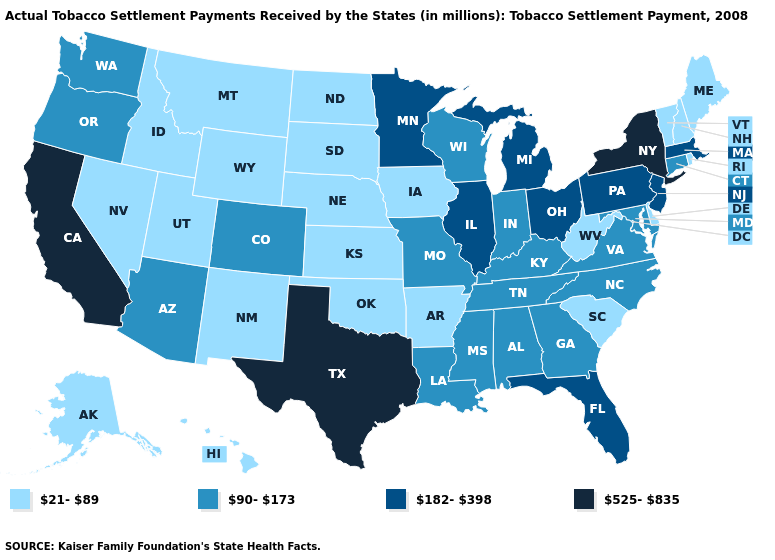Among the states that border Massachusetts , which have the lowest value?
Be succinct. New Hampshire, Rhode Island, Vermont. What is the value of Nebraska?
Write a very short answer. 21-89. Does New York have a higher value than Texas?
Concise answer only. No. Name the states that have a value in the range 90-173?
Write a very short answer. Alabama, Arizona, Colorado, Connecticut, Georgia, Indiana, Kentucky, Louisiana, Maryland, Mississippi, Missouri, North Carolina, Oregon, Tennessee, Virginia, Washington, Wisconsin. Name the states that have a value in the range 525-835?
Concise answer only. California, New York, Texas. Among the states that border Iowa , does South Dakota have the highest value?
Quick response, please. No. Does Wyoming have a lower value than California?
Concise answer only. Yes. What is the value of New York?
Concise answer only. 525-835. Is the legend a continuous bar?
Keep it brief. No. Does Oklahoma have the same value as Iowa?
Quick response, please. Yes. What is the value of North Dakota?
Short answer required. 21-89. Does Oregon have a higher value than Indiana?
Short answer required. No. Name the states that have a value in the range 182-398?
Write a very short answer. Florida, Illinois, Massachusetts, Michigan, Minnesota, New Jersey, Ohio, Pennsylvania. Name the states that have a value in the range 90-173?
Short answer required. Alabama, Arizona, Colorado, Connecticut, Georgia, Indiana, Kentucky, Louisiana, Maryland, Mississippi, Missouri, North Carolina, Oregon, Tennessee, Virginia, Washington, Wisconsin. 